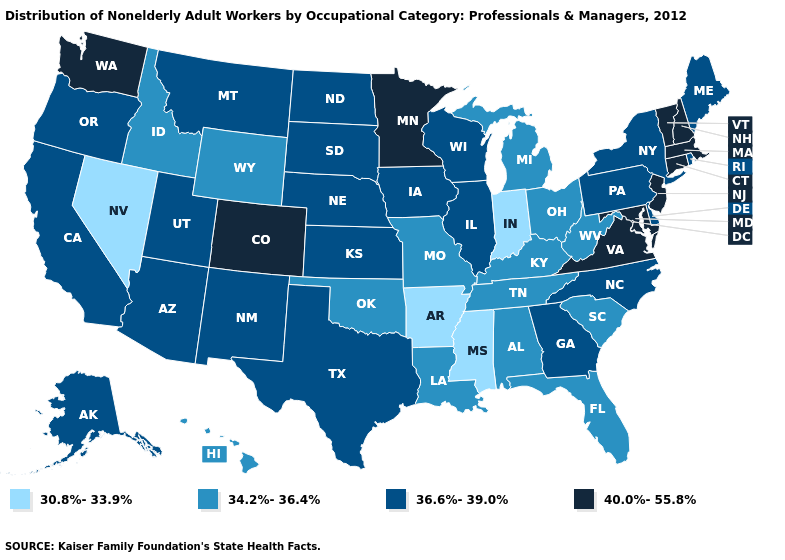Among the states that border Virginia , does West Virginia have the lowest value?
Short answer required. Yes. Which states have the highest value in the USA?
Short answer required. Colorado, Connecticut, Maryland, Massachusetts, Minnesota, New Hampshire, New Jersey, Vermont, Virginia, Washington. Name the states that have a value in the range 36.6%-39.0%?
Write a very short answer. Alaska, Arizona, California, Delaware, Georgia, Illinois, Iowa, Kansas, Maine, Montana, Nebraska, New Mexico, New York, North Carolina, North Dakota, Oregon, Pennsylvania, Rhode Island, South Dakota, Texas, Utah, Wisconsin. What is the highest value in the USA?
Short answer required. 40.0%-55.8%. Does Arkansas have the lowest value in the South?
Give a very brief answer. Yes. What is the highest value in the USA?
Be succinct. 40.0%-55.8%. Name the states that have a value in the range 36.6%-39.0%?
Keep it brief. Alaska, Arizona, California, Delaware, Georgia, Illinois, Iowa, Kansas, Maine, Montana, Nebraska, New Mexico, New York, North Carolina, North Dakota, Oregon, Pennsylvania, Rhode Island, South Dakota, Texas, Utah, Wisconsin. Which states have the highest value in the USA?
Answer briefly. Colorado, Connecticut, Maryland, Massachusetts, Minnesota, New Hampshire, New Jersey, Vermont, Virginia, Washington. Name the states that have a value in the range 34.2%-36.4%?
Concise answer only. Alabama, Florida, Hawaii, Idaho, Kentucky, Louisiana, Michigan, Missouri, Ohio, Oklahoma, South Carolina, Tennessee, West Virginia, Wyoming. Name the states that have a value in the range 34.2%-36.4%?
Be succinct. Alabama, Florida, Hawaii, Idaho, Kentucky, Louisiana, Michigan, Missouri, Ohio, Oklahoma, South Carolina, Tennessee, West Virginia, Wyoming. Does Nevada have the lowest value in the West?
Quick response, please. Yes. What is the value of West Virginia?
Keep it brief. 34.2%-36.4%. Name the states that have a value in the range 30.8%-33.9%?
Short answer required. Arkansas, Indiana, Mississippi, Nevada. Name the states that have a value in the range 36.6%-39.0%?
Give a very brief answer. Alaska, Arizona, California, Delaware, Georgia, Illinois, Iowa, Kansas, Maine, Montana, Nebraska, New Mexico, New York, North Carolina, North Dakota, Oregon, Pennsylvania, Rhode Island, South Dakota, Texas, Utah, Wisconsin. Does Colorado have the highest value in the West?
Give a very brief answer. Yes. 